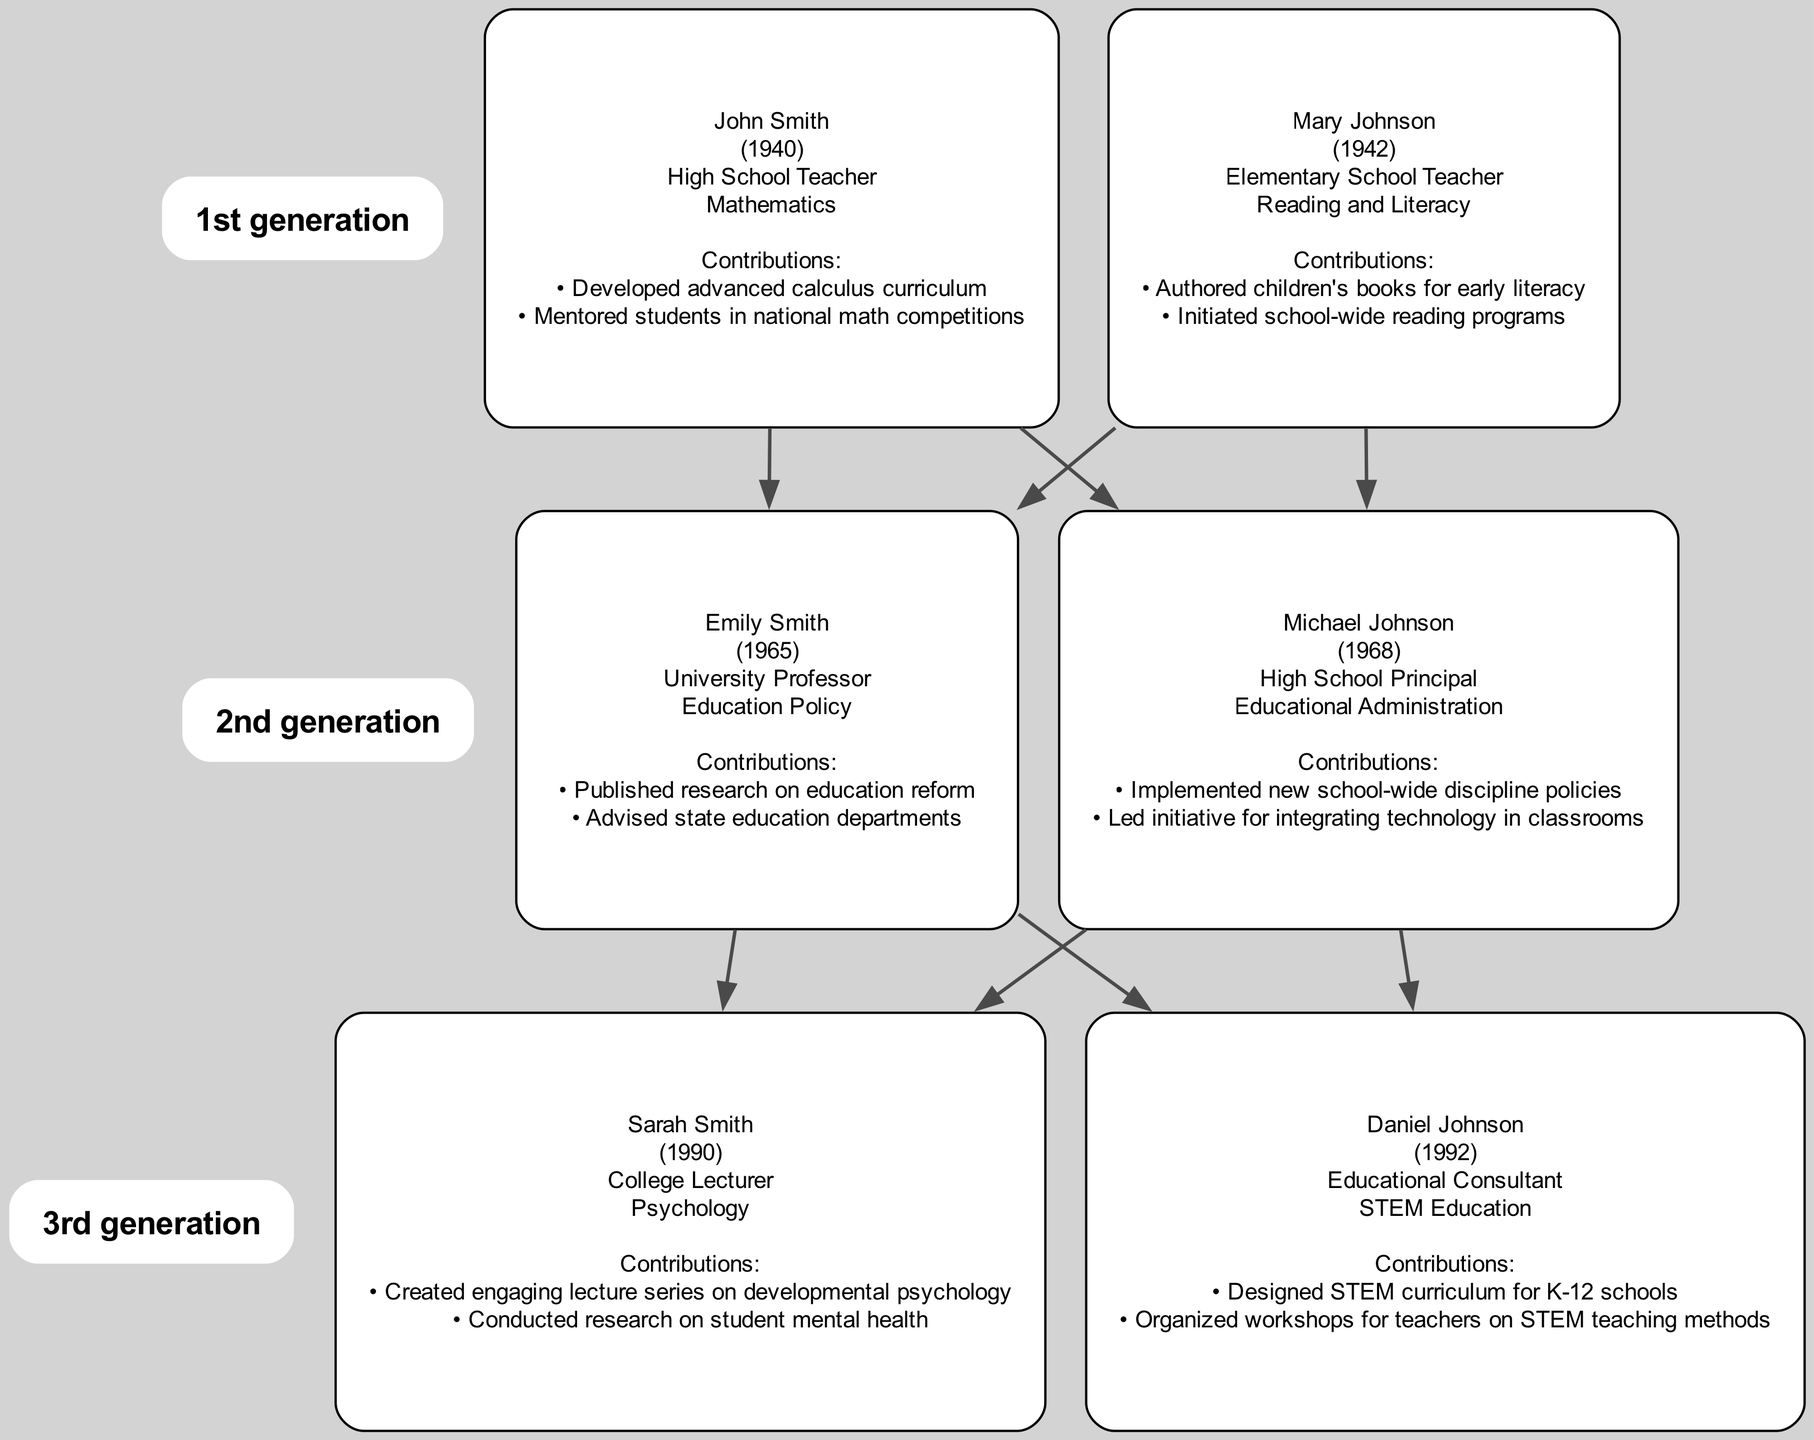What education role did John Smith have? According to the diagram, John Smith served as a High School Teacher in the field of Mathematics. This information is directly derived from the data associated with his node.
Answer: High School Teacher Which generation does Emily Smith belong to? Referring to the diagram, Emily Smith is part of the 2nd generation. The generations are clearly delineated, showing which members belong to which generation.
Answer: 2nd generation How many contributions did Mary Johnson make? From the diagram, Mary Johnson has two listed contributions: authoring children's books for early literacy and initiating school-wide reading programs. This is clearly outlined in her node.
Answer: 2 What is the field of expertise for Sarah Smith? The diagram indicates that Sarah Smith specializes in Psychology. This is noted in her node, which outlines her education role and field of expertise.
Answer: Psychology Which family member advised state education departments? The diagram shows that Emily Smith is the family member who advised state education departments. This is one of her contributions listed in her node.
Answer: Emily Smith How many members are there in the 3rd generation? The diagram defines that there are two members in the 3rd generation: Sarah Smith and Daniel Johnson. This can be confirmed by counting the members in that generation from the diagram.
Answer: 2 Who developed the advanced calculus curriculum? According to the diagram, the advanced calculus curriculum was developed by John Smith, as this is one of his contributions noted in his node.
Answer: John Smith What role does Daniel Johnson fulfill? The diagram clearly states that Daniel Johnson serves as an Educational Consultant. This information is found alongside his name in the diagram.
Answer: Educational Consultant Which generation includes the role of High School Principal? The diagram indicates that Michael Johnson, who has the role of High School Principal, belongs to the 2nd generation. The connections are structured by generation, making it clear.
Answer: 2nd generation 